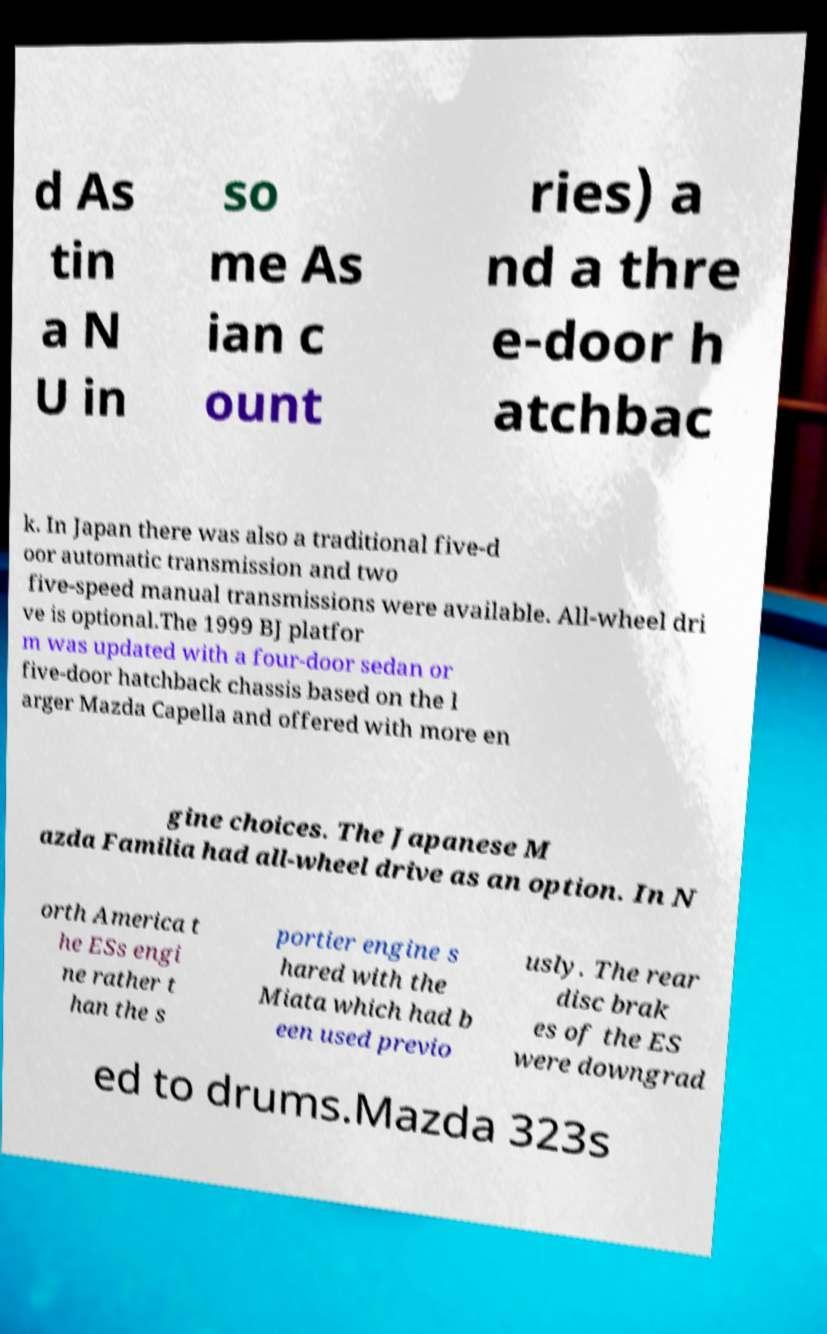Please identify and transcribe the text found in this image. d As tin a N U in so me As ian c ount ries) a nd a thre e-door h atchbac k. In Japan there was also a traditional five-d oor automatic transmission and two five-speed manual transmissions were available. All-wheel dri ve is optional.The 1999 BJ platfor m was updated with a four-door sedan or five-door hatchback chassis based on the l arger Mazda Capella and offered with more en gine choices. The Japanese M azda Familia had all-wheel drive as an option. In N orth America t he ESs engi ne rather t han the s portier engine s hared with the Miata which had b een used previo usly. The rear disc brak es of the ES were downgrad ed to drums.Mazda 323s 